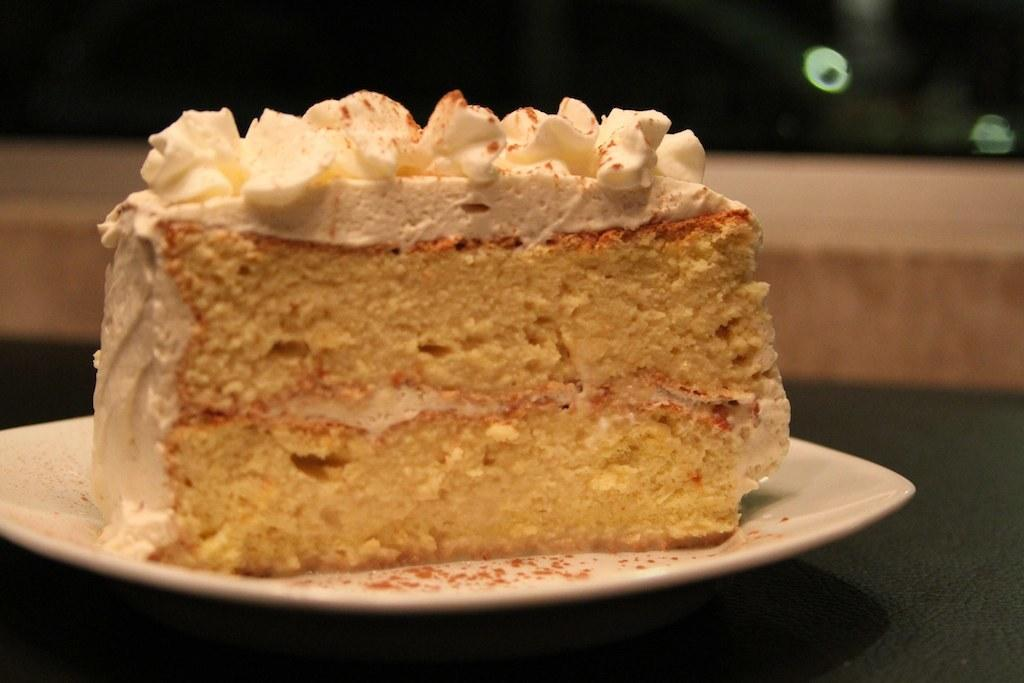What is on the plate that is visible in the image? There is a piece of cake on a plate in the image. Can you see a flock of birds flying over the cake in the image? There is no flock of birds visible in the image; it only features a piece of cake on a plate. Is there a wrench or basketball present in the image? No, there is no wrench or basketball present in the image. 